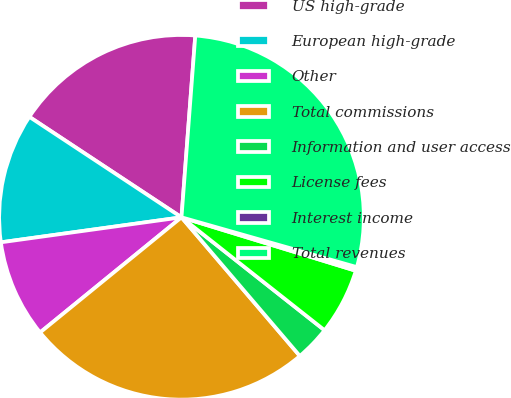Convert chart to OTSL. <chart><loc_0><loc_0><loc_500><loc_500><pie_chart><fcel>US high-grade<fcel>European high-grade<fcel>Other<fcel>Total commissions<fcel>Information and user access<fcel>License fees<fcel>Interest income<fcel>Total revenues<nl><fcel>16.92%<fcel>11.48%<fcel>8.69%<fcel>25.37%<fcel>3.12%<fcel>5.9%<fcel>0.33%<fcel>28.2%<nl></chart> 